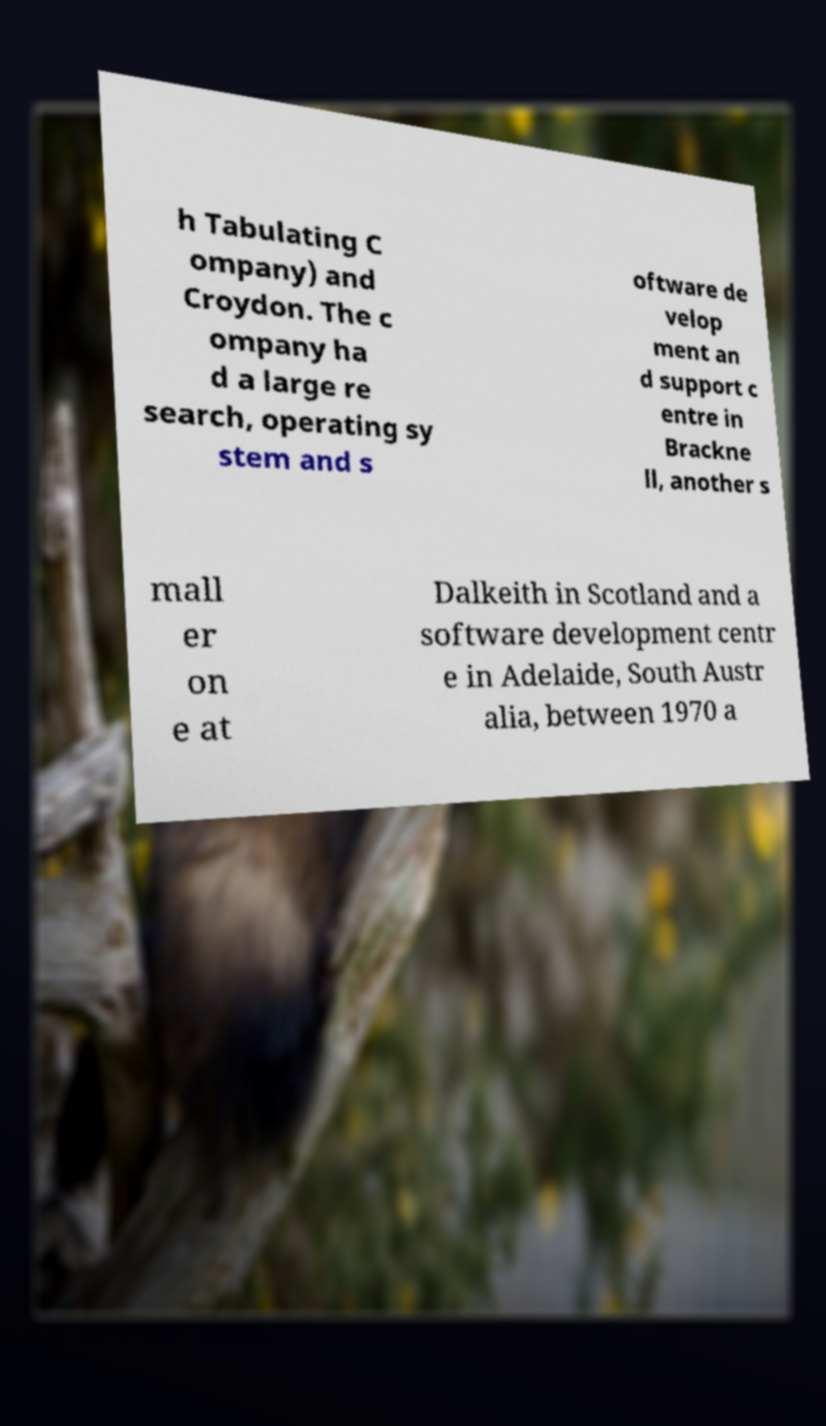Could you extract and type out the text from this image? h Tabulating C ompany) and Croydon. The c ompany ha d a large re search, operating sy stem and s oftware de velop ment an d support c entre in Brackne ll, another s mall er on e at Dalkeith in Scotland and a software development centr e in Adelaide, South Austr alia, between 1970 a 